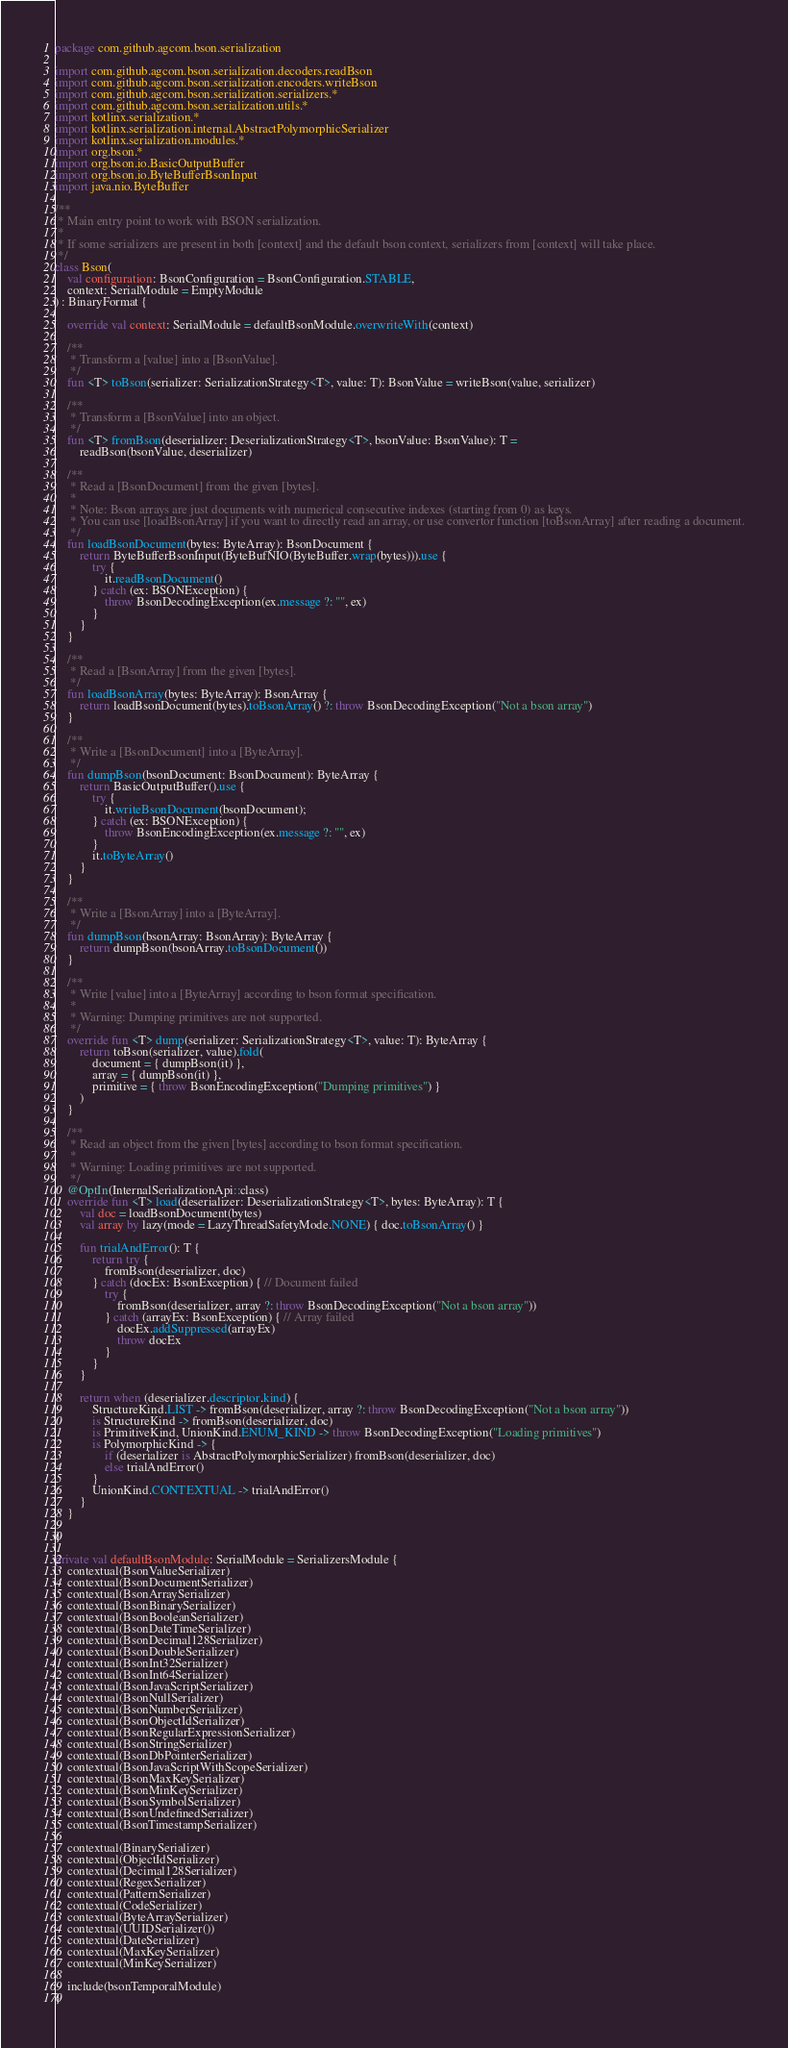<code> <loc_0><loc_0><loc_500><loc_500><_Kotlin_>package com.github.agcom.bson.serialization

import com.github.agcom.bson.serialization.decoders.readBson
import com.github.agcom.bson.serialization.encoders.writeBson
import com.github.agcom.bson.serialization.serializers.*
import com.github.agcom.bson.serialization.utils.*
import kotlinx.serialization.*
import kotlinx.serialization.internal.AbstractPolymorphicSerializer
import kotlinx.serialization.modules.*
import org.bson.*
import org.bson.io.BasicOutputBuffer
import org.bson.io.ByteBufferBsonInput
import java.nio.ByteBuffer

/**
 * Main entry point to work with BSON serialization.
 *
 * If some serializers are present in both [context] and the default bson context, serializers from [context] will take place.
 */
class Bson(
    val configuration: BsonConfiguration = BsonConfiguration.STABLE,
    context: SerialModule = EmptyModule
) : BinaryFormat {

    override val context: SerialModule = defaultBsonModule.overwriteWith(context)

    /**
     * Transform a [value] into a [BsonValue].
     */
    fun <T> toBson(serializer: SerializationStrategy<T>, value: T): BsonValue = writeBson(value, serializer)

    /**
     * Transform a [BsonValue] into an object.
     */
    fun <T> fromBson(deserializer: DeserializationStrategy<T>, bsonValue: BsonValue): T =
        readBson(bsonValue, deserializer)

    /**
     * Read a [BsonDocument] from the given [bytes].
     *
     * Note: Bson arrays are just documents with numerical consecutive indexes (starting from 0) as keys.
     * You can use [loadBsonArray] if you want to directly read an array, or use convertor function [toBsonArray] after reading a document.
     */
    fun loadBsonDocument(bytes: ByteArray): BsonDocument {
        return ByteBufferBsonInput(ByteBufNIO(ByteBuffer.wrap(bytes))).use {
            try {
                it.readBsonDocument()
            } catch (ex: BSONException) {
                throw BsonDecodingException(ex.message ?: "", ex)
            }
        }
    }

    /**
     * Read a [BsonArray] from the given [bytes].
     */
    fun loadBsonArray(bytes: ByteArray): BsonArray {
        return loadBsonDocument(bytes).toBsonArray() ?: throw BsonDecodingException("Not a bson array")
    }

    /**
     * Write a [BsonDocument] into a [ByteArray].
     */
    fun dumpBson(bsonDocument: BsonDocument): ByteArray {
        return BasicOutputBuffer().use {
            try {
                it.writeBsonDocument(bsonDocument);
            } catch (ex: BSONException) {
                throw BsonEncodingException(ex.message ?: "", ex)
            }
            it.toByteArray()
        }
    }

    /**
     * Write a [BsonArray] into a [ByteArray].
     */
    fun dumpBson(bsonArray: BsonArray): ByteArray {
        return dumpBson(bsonArray.toBsonDocument())
    }

    /**
     * Write [value] into a [ByteArray] according to bson format specification.
     *
     * Warning: Dumping primitives are not supported.
     */
    override fun <T> dump(serializer: SerializationStrategy<T>, value: T): ByteArray {
        return toBson(serializer, value).fold(
            document = { dumpBson(it) },
            array = { dumpBson(it) },
            primitive = { throw BsonEncodingException("Dumping primitives") }
        )
    }

    /**
     * Read an object from the given [bytes] according to bson format specification.
     *
     * Warning: Loading primitives are not supported.
     */
    @OptIn(InternalSerializationApi::class)
    override fun <T> load(deserializer: DeserializationStrategy<T>, bytes: ByteArray): T {
        val doc = loadBsonDocument(bytes)
        val array by lazy(mode = LazyThreadSafetyMode.NONE) { doc.toBsonArray() }

        fun trialAndError(): T {
            return try {
                fromBson(deserializer, doc)
            } catch (docEx: BsonException) { // Document failed
                try {
                    fromBson(deserializer, array ?: throw BsonDecodingException("Not a bson array"))
                } catch (arrayEx: BsonException) { // Array failed
                    docEx.addSuppressed(arrayEx)
                    throw docEx
                }
            }
        }

        return when (deserializer.descriptor.kind) {
            StructureKind.LIST -> fromBson(deserializer, array ?: throw BsonDecodingException("Not a bson array"))
            is StructureKind -> fromBson(deserializer, doc)
            is PrimitiveKind, UnionKind.ENUM_KIND -> throw BsonDecodingException("Loading primitives")
            is PolymorphicKind -> {
                if (deserializer is AbstractPolymorphicSerializer) fromBson(deserializer, doc)
                else trialAndError()
            }
            UnionKind.CONTEXTUAL -> trialAndError()
        }
    }

}

private val defaultBsonModule: SerialModule = SerializersModule {
    contextual(BsonValueSerializer)
    contextual(BsonDocumentSerializer)
    contextual(BsonArraySerializer)
    contextual(BsonBinarySerializer)
    contextual(BsonBooleanSerializer)
    contextual(BsonDateTimeSerializer)
    contextual(BsonDecimal128Serializer)
    contextual(BsonDoubleSerializer)
    contextual(BsonInt32Serializer)
    contextual(BsonInt64Serializer)
    contextual(BsonJavaScriptSerializer)
    contextual(BsonNullSerializer)
    contextual(BsonNumberSerializer)
    contextual(BsonObjectIdSerializer)
    contextual(BsonRegularExpressionSerializer)
    contextual(BsonStringSerializer)
    contextual(BsonDbPointerSerializer)
    contextual(BsonJavaScriptWithScopeSerializer)
    contextual(BsonMaxKeySerializer)
    contextual(BsonMinKeySerializer)
    contextual(BsonSymbolSerializer)
    contextual(BsonUndefinedSerializer)
    contextual(BsonTimestampSerializer)

    contextual(BinarySerializer)
    contextual(ObjectIdSerializer)
    contextual(Decimal128Serializer)
    contextual(RegexSerializer)
    contextual(PatternSerializer)
    contextual(CodeSerializer)
    contextual(ByteArraySerializer)
    contextual(UUIDSerializer())
    contextual(DateSerializer)
    contextual(MaxKeySerializer)
    contextual(MinKeySerializer)

    include(bsonTemporalModule)
}</code> 